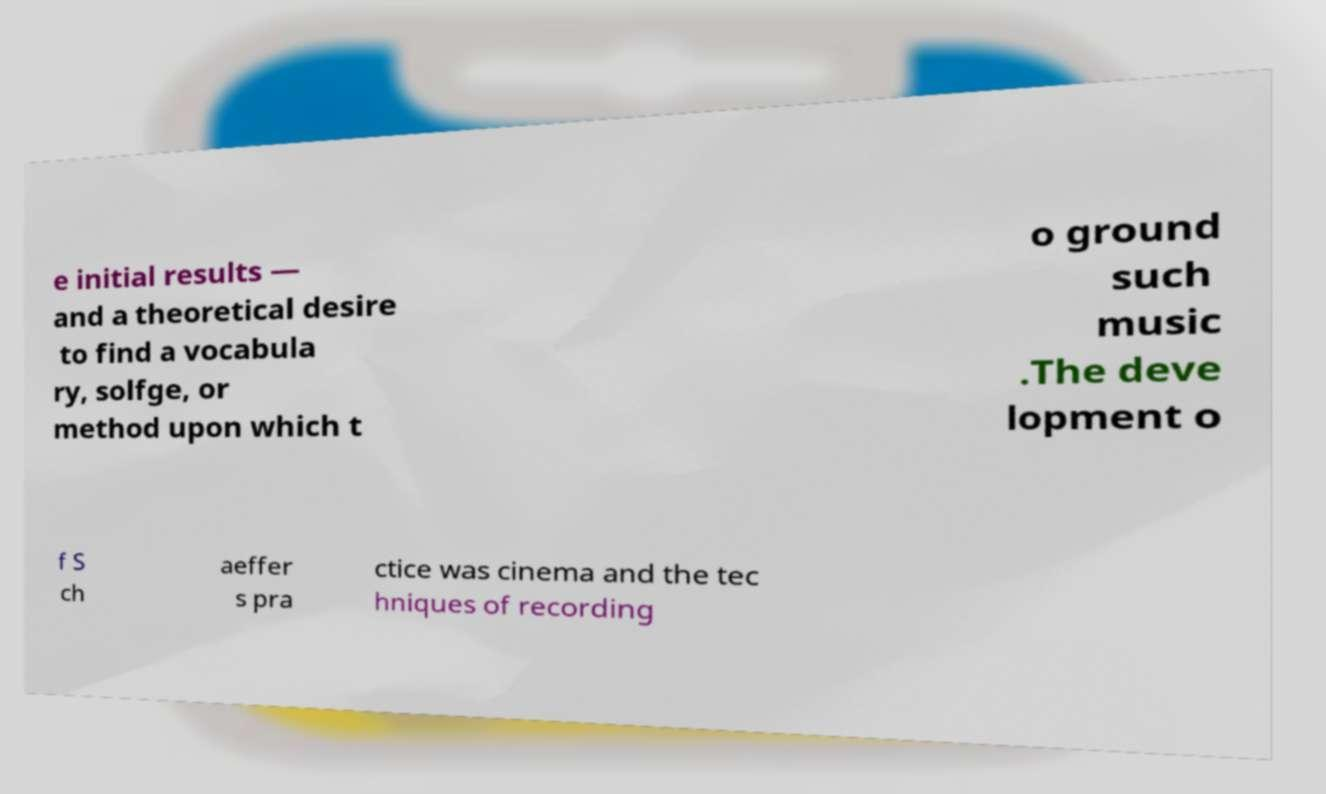For documentation purposes, I need the text within this image transcribed. Could you provide that? e initial results — and a theoretical desire to find a vocabula ry, solfge, or method upon which t o ground such music .The deve lopment o f S ch aeffer s pra ctice was cinema and the tec hniques of recording 